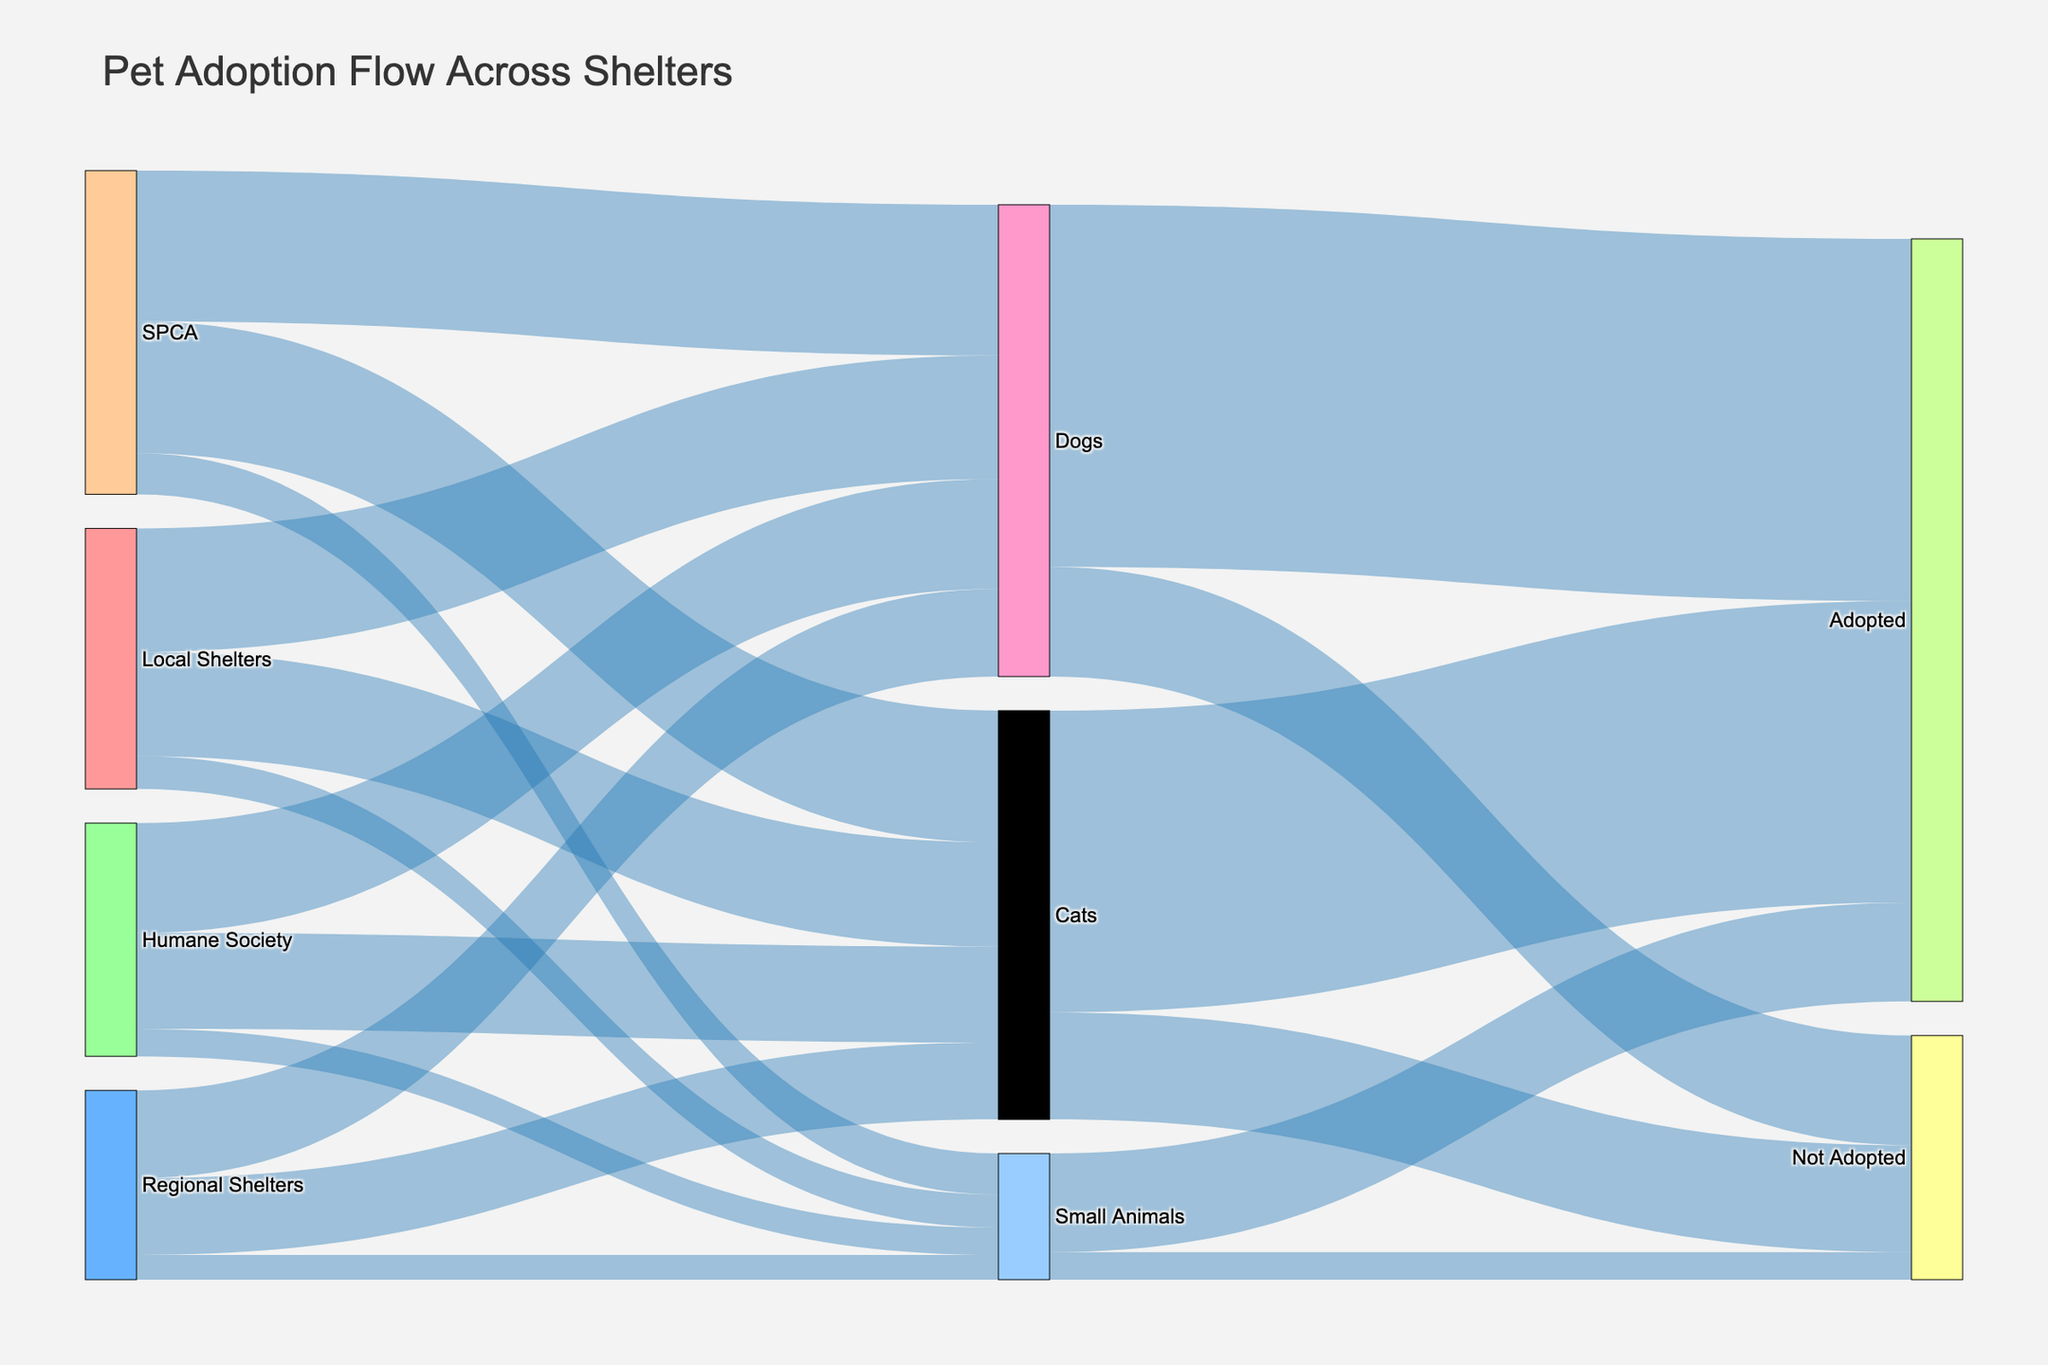What is the title of the figure? The title of the figure is displayed at the top of the Sankey Diagram. By referring to the figure, you can see the large text that describes what the data is about.
Answer: Pet Adoption Flow Across Shelters Which shelter has the highest number of adopted dogs? To find this, locate the nodes representing each shelter, and then see which one connects with the 'Dogs' target with the highest value. From there, follow the flow to the 'Adopted' target associated with 'Dogs'.
Answer: SPCA How many small animals were not adopted? To find the number of small animals not adopted, look at the link originating from 'Small Animals' node going to 'Not Adopted' node.
Answer: 100 What is the total number of cats processed across all shelters? Sum up the values of all links coming from various shelters (Local Shelters, Regional Shelters, SPCA, Humane Society) that lead to 'Cats'.
Answer: 380 + 280 + 480 + 350 = 1490 What is the ratio of adopted to not adopted dogs? Identify the values of links going from 'Dogs' to 'Adopted' and 'Not Adopted', and then calculate the ratio by dividing the number of adopted dogs by the number of dogs not adopted.
Answer: 1320 / 400 = 3.3 Which species has the highest adoption rate? Compare the adoption rates by looking at the links going from each species to 'Adopted'.
Answer: Dogs (1320) Which shelter has the least number of cats? Look at all the shelters that flow into 'Cats' and identify the one with the smallest link value.
Answer: Regional Shelters What is the total number of pets handled by the SPCA? Sum the values of the links flowing out of the 'SPCA' node to the species nodes (Dogs, Cats, Small Animals).
Answer: 550 + 480 + 150 = 1180 